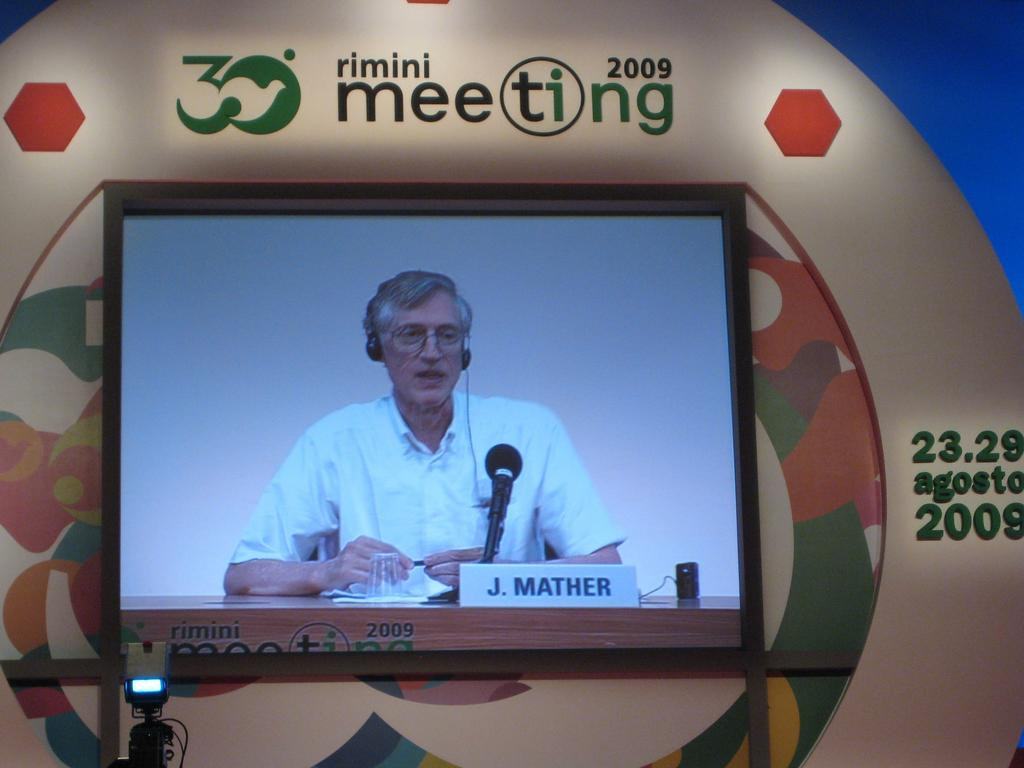<image>
Offer a succinct explanation of the picture presented. A screen shows J. Mather speaking into a microphone. 